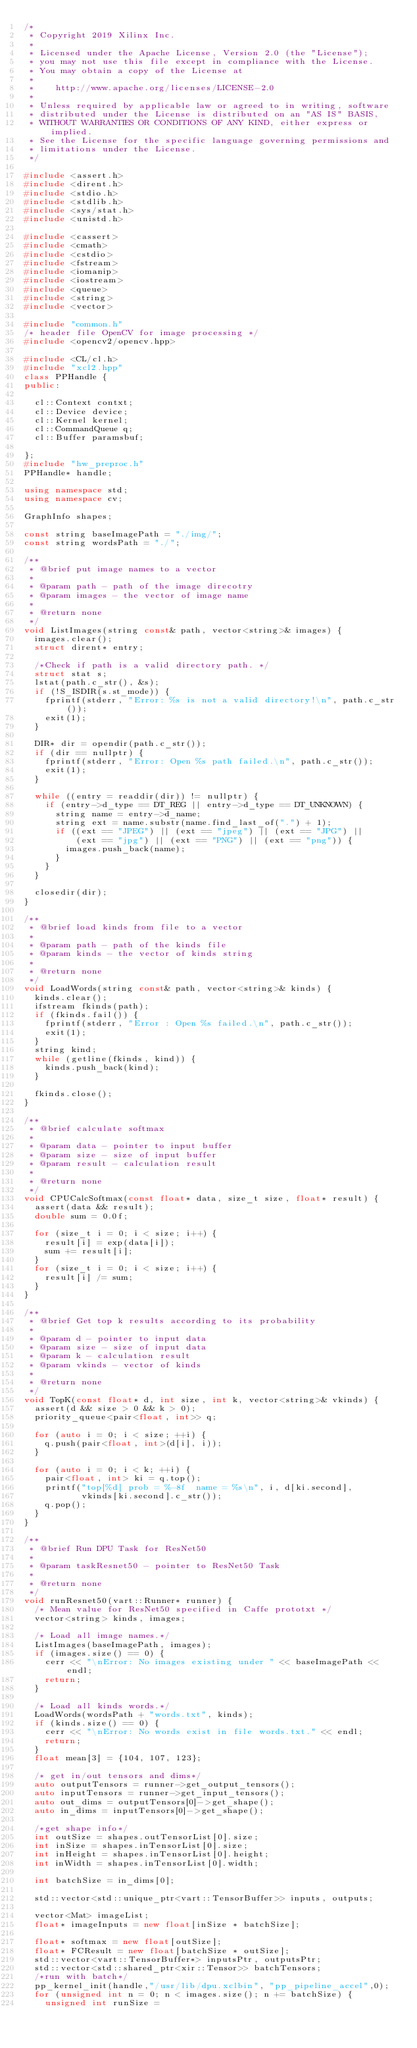<code> <loc_0><loc_0><loc_500><loc_500><_C++_>/*
 * Copyright 2019 Xilinx Inc.
 *
 * Licensed under the Apache License, Version 2.0 (the "License");
 * you may not use this file except in compliance with the License.
 * You may obtain a copy of the License at
 *
 *    http://www.apache.org/licenses/LICENSE-2.0
 *
 * Unless required by applicable law or agreed to in writing, software
 * distributed under the License is distributed on an "AS IS" BASIS,
 * WITHOUT WARRANTIES OR CONDITIONS OF ANY KIND, either express or implied.
 * See the License for the specific language governing permissions and
 * limitations under the License.
 */

#include <assert.h>
#include <dirent.h>
#include <stdio.h>
#include <stdlib.h>
#include <sys/stat.h>
#include <unistd.h>

#include <cassert>
#include <cmath>
#include <cstdio>
#include <fstream>
#include <iomanip>
#include <iostream>
#include <queue>
#include <string>
#include <vector>

#include "common.h"
/* header file OpenCV for image processing */
#include <opencv2/opencv.hpp>

#include <CL/cl.h>
#include "xcl2.hpp"
class PPHandle {
public:

  cl::Context contxt;
  cl::Device device;
  cl::Kernel kernel;
  cl::CommandQueue q;
  cl::Buffer paramsbuf;

};
#include "hw_preproc.h"
PPHandle* handle;

using namespace std;
using namespace cv;

GraphInfo shapes;

const string baseImagePath = "./img/";
const string wordsPath = "./";

/**
 * @brief put image names to a vector
 *
 * @param path - path of the image direcotry
 * @param images - the vector of image name
 *
 * @return none
 */
void ListImages(string const& path, vector<string>& images) {
  images.clear();
  struct dirent* entry;

  /*Check if path is a valid directory path. */
  struct stat s;
  lstat(path.c_str(), &s);
  if (!S_ISDIR(s.st_mode)) {
    fprintf(stderr, "Error: %s is not a valid directory!\n", path.c_str());
    exit(1);
  }

  DIR* dir = opendir(path.c_str());
  if (dir == nullptr) {
    fprintf(stderr, "Error: Open %s path failed.\n", path.c_str());
    exit(1);
  }

  while ((entry = readdir(dir)) != nullptr) {
    if (entry->d_type == DT_REG || entry->d_type == DT_UNKNOWN) {
      string name = entry->d_name;
      string ext = name.substr(name.find_last_of(".") + 1);
      if ((ext == "JPEG") || (ext == "jpeg") || (ext == "JPG") ||
          (ext == "jpg") || (ext == "PNG") || (ext == "png")) {
        images.push_back(name);
      }
    }
  }

  closedir(dir);
}

/**
 * @brief load kinds from file to a vector
 *
 * @param path - path of the kinds file
 * @param kinds - the vector of kinds string
 *
 * @return none
 */
void LoadWords(string const& path, vector<string>& kinds) {
  kinds.clear();
  ifstream fkinds(path);
  if (fkinds.fail()) {
    fprintf(stderr, "Error : Open %s failed.\n", path.c_str());
    exit(1);
  }
  string kind;
  while (getline(fkinds, kind)) {
    kinds.push_back(kind);
  }

  fkinds.close();
}

/**
 * @brief calculate softmax
 *
 * @param data - pointer to input buffer
 * @param size - size of input buffer
 * @param result - calculation result
 *
 * @return none
 */
void CPUCalcSoftmax(const float* data, size_t size, float* result) {
  assert(data && result);
  double sum = 0.0f;

  for (size_t i = 0; i < size; i++) {
    result[i] = exp(data[i]);
    sum += result[i];
  }
  for (size_t i = 0; i < size; i++) {
    result[i] /= sum;
  }
}

/**
 * @brief Get top k results according to its probability
 *
 * @param d - pointer to input data
 * @param size - size of input data
 * @param k - calculation result
 * @param vkinds - vector of kinds
 *
 * @return none
 */
void TopK(const float* d, int size, int k, vector<string>& vkinds) {
  assert(d && size > 0 && k > 0);
  priority_queue<pair<float, int>> q;

  for (auto i = 0; i < size; ++i) {
    q.push(pair<float, int>(d[i], i));
  }

  for (auto i = 0; i < k; ++i) {
    pair<float, int> ki = q.top();
    printf("top[%d] prob = %-8f  name = %s\n", i, d[ki.second],
           vkinds[ki.second].c_str());
    q.pop();
  }
}

/**
 * @brief Run DPU Task for ResNet50
 *
 * @param taskResnet50 - pointer to ResNet50 Task
 *
 * @return none
 */
void runResnet50(vart::Runner* runner) {
  /* Mean value for ResNet50 specified in Caffe prototxt */
  vector<string> kinds, images;

  /* Load all image names.*/
  ListImages(baseImagePath, images);
  if (images.size() == 0) {
    cerr << "\nError: No images existing under " << baseImagePath << endl;
    return;
  }

  /* Load all kinds words.*/
  LoadWords(wordsPath + "words.txt", kinds);
  if (kinds.size() == 0) {
    cerr << "\nError: No words exist in file words.txt." << endl;
    return;
  }
  float mean[3] = {104, 107, 123};

  /* get in/out tensors and dims*/
  auto outputTensors = runner->get_output_tensors();
  auto inputTensors = runner->get_input_tensors();
  auto out_dims = outputTensors[0]->get_shape();
  auto in_dims = inputTensors[0]->get_shape();

  /*get shape info*/
  int outSize = shapes.outTensorList[0].size;
  int inSize = shapes.inTensorList[0].size;
  int inHeight = shapes.inTensorList[0].height;
  int inWidth = shapes.inTensorList[0].width;

  int batchSize = in_dims[0];

  std::vector<std::unique_ptr<vart::TensorBuffer>> inputs, outputs;

  vector<Mat> imageList;
  float* imageInputs = new float[inSize * batchSize];

  float* softmax = new float[outSize];
  float* FCResult = new float[batchSize * outSize];
  std::vector<vart::TensorBuffer*> inputsPtr, outputsPtr;
  std::vector<std::shared_ptr<xir::Tensor>> batchTensors;
  /*run with batch*/
  pp_kernel_init(handle,"/usr/lib/dpu.xclbin", "pp_pipeline_accel",0);
  for (unsigned int n = 0; n < images.size(); n += batchSize) {
    unsigned int runSize =</code> 